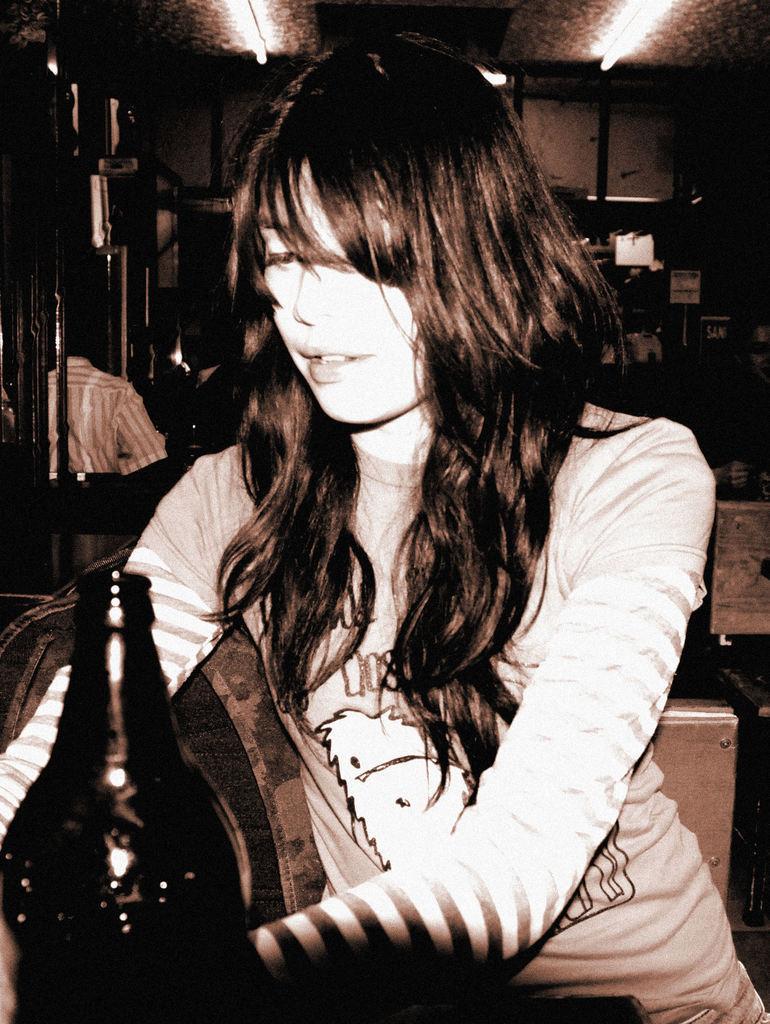Could you give a brief overview of what you see in this image? In this image we can see a girl. She is wearing a T-shirt. There is a bottle in the left bottom of the image. In the background, we can see a man, cupboard and objects. There is a person on the right side of the image. At the top of the image, we can see lights attached to the roof. 